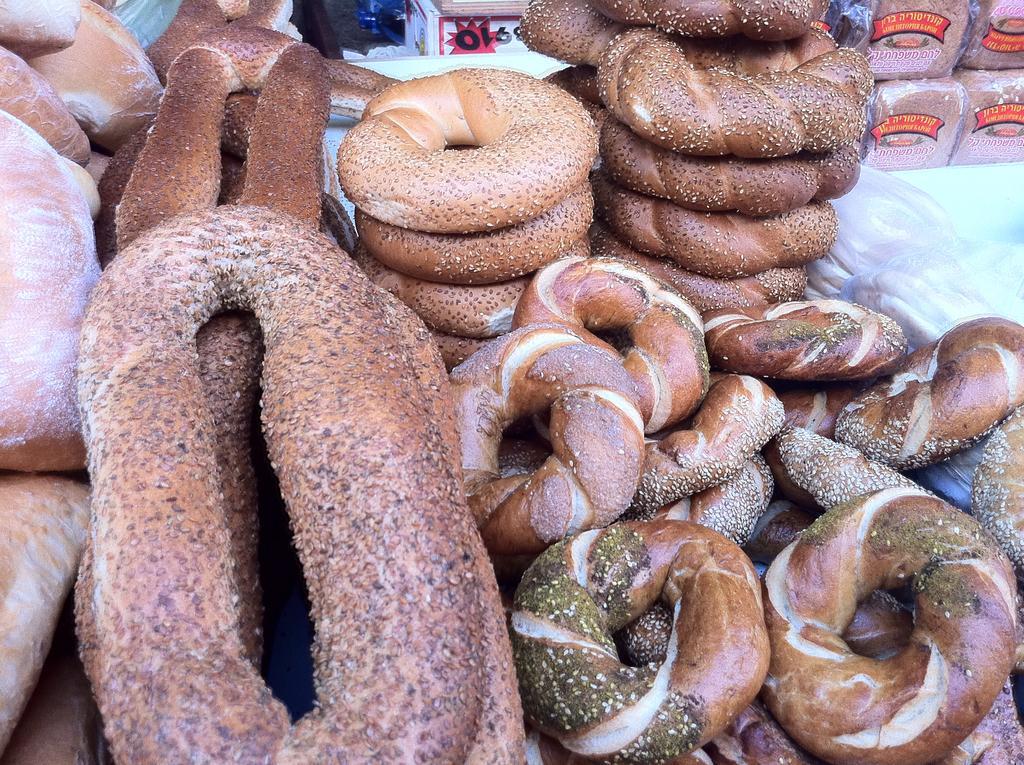In one or two sentences, can you explain what this image depicts? In the foreground of this picture, there are many donuts on the table. In the background, we can see a table and bread packets. 